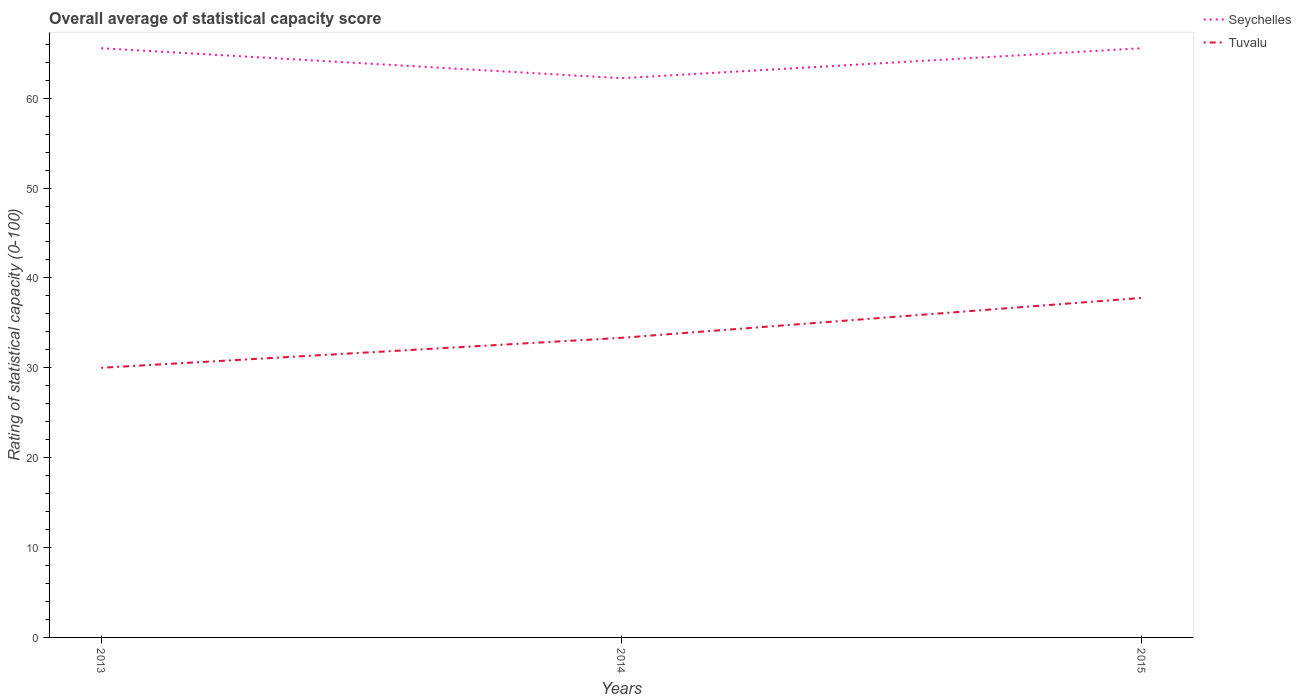Does the line corresponding to Seychelles intersect with the line corresponding to Tuvalu?
Provide a succinct answer. No. Is the number of lines equal to the number of legend labels?
Offer a terse response. Yes. What is the total rating of statistical capacity in Tuvalu in the graph?
Make the answer very short. -4.44. What is the difference between the highest and the second highest rating of statistical capacity in Seychelles?
Provide a short and direct response. 3.33. How many lines are there?
Give a very brief answer. 2. How many years are there in the graph?
Make the answer very short. 3. What is the difference between two consecutive major ticks on the Y-axis?
Your answer should be compact. 10. Are the values on the major ticks of Y-axis written in scientific E-notation?
Provide a short and direct response. No. Does the graph contain any zero values?
Offer a very short reply. No. Does the graph contain grids?
Give a very brief answer. No. Where does the legend appear in the graph?
Keep it short and to the point. Top right. How many legend labels are there?
Give a very brief answer. 2. What is the title of the graph?
Your answer should be very brief. Overall average of statistical capacity score. What is the label or title of the X-axis?
Provide a short and direct response. Years. What is the label or title of the Y-axis?
Your answer should be very brief. Rating of statistical capacity (0-100). What is the Rating of statistical capacity (0-100) in Seychelles in 2013?
Make the answer very short. 65.56. What is the Rating of statistical capacity (0-100) of Seychelles in 2014?
Provide a short and direct response. 62.22. What is the Rating of statistical capacity (0-100) of Tuvalu in 2014?
Keep it short and to the point. 33.33. What is the Rating of statistical capacity (0-100) in Seychelles in 2015?
Provide a succinct answer. 65.56. What is the Rating of statistical capacity (0-100) in Tuvalu in 2015?
Provide a short and direct response. 37.78. Across all years, what is the maximum Rating of statistical capacity (0-100) in Seychelles?
Provide a succinct answer. 65.56. Across all years, what is the maximum Rating of statistical capacity (0-100) in Tuvalu?
Make the answer very short. 37.78. Across all years, what is the minimum Rating of statistical capacity (0-100) of Seychelles?
Offer a very short reply. 62.22. What is the total Rating of statistical capacity (0-100) in Seychelles in the graph?
Your answer should be compact. 193.33. What is the total Rating of statistical capacity (0-100) of Tuvalu in the graph?
Keep it short and to the point. 101.11. What is the difference between the Rating of statistical capacity (0-100) in Seychelles in 2013 and that in 2014?
Ensure brevity in your answer.  3.33. What is the difference between the Rating of statistical capacity (0-100) of Tuvalu in 2013 and that in 2014?
Offer a terse response. -3.33. What is the difference between the Rating of statistical capacity (0-100) in Tuvalu in 2013 and that in 2015?
Ensure brevity in your answer.  -7.78. What is the difference between the Rating of statistical capacity (0-100) of Seychelles in 2014 and that in 2015?
Give a very brief answer. -3.33. What is the difference between the Rating of statistical capacity (0-100) in Tuvalu in 2014 and that in 2015?
Provide a short and direct response. -4.44. What is the difference between the Rating of statistical capacity (0-100) in Seychelles in 2013 and the Rating of statistical capacity (0-100) in Tuvalu in 2014?
Give a very brief answer. 32.22. What is the difference between the Rating of statistical capacity (0-100) in Seychelles in 2013 and the Rating of statistical capacity (0-100) in Tuvalu in 2015?
Offer a very short reply. 27.78. What is the difference between the Rating of statistical capacity (0-100) of Seychelles in 2014 and the Rating of statistical capacity (0-100) of Tuvalu in 2015?
Your answer should be very brief. 24.44. What is the average Rating of statistical capacity (0-100) of Seychelles per year?
Offer a very short reply. 64.44. What is the average Rating of statistical capacity (0-100) of Tuvalu per year?
Keep it short and to the point. 33.7. In the year 2013, what is the difference between the Rating of statistical capacity (0-100) in Seychelles and Rating of statistical capacity (0-100) in Tuvalu?
Your answer should be compact. 35.56. In the year 2014, what is the difference between the Rating of statistical capacity (0-100) of Seychelles and Rating of statistical capacity (0-100) of Tuvalu?
Provide a short and direct response. 28.89. In the year 2015, what is the difference between the Rating of statistical capacity (0-100) of Seychelles and Rating of statistical capacity (0-100) of Tuvalu?
Your answer should be very brief. 27.78. What is the ratio of the Rating of statistical capacity (0-100) of Seychelles in 2013 to that in 2014?
Your answer should be compact. 1.05. What is the ratio of the Rating of statistical capacity (0-100) in Seychelles in 2013 to that in 2015?
Offer a very short reply. 1. What is the ratio of the Rating of statistical capacity (0-100) of Tuvalu in 2013 to that in 2015?
Provide a short and direct response. 0.79. What is the ratio of the Rating of statistical capacity (0-100) of Seychelles in 2014 to that in 2015?
Offer a terse response. 0.95. What is the ratio of the Rating of statistical capacity (0-100) in Tuvalu in 2014 to that in 2015?
Ensure brevity in your answer.  0.88. What is the difference between the highest and the second highest Rating of statistical capacity (0-100) in Tuvalu?
Keep it short and to the point. 4.44. What is the difference between the highest and the lowest Rating of statistical capacity (0-100) of Seychelles?
Offer a terse response. 3.33. What is the difference between the highest and the lowest Rating of statistical capacity (0-100) in Tuvalu?
Your answer should be very brief. 7.78. 